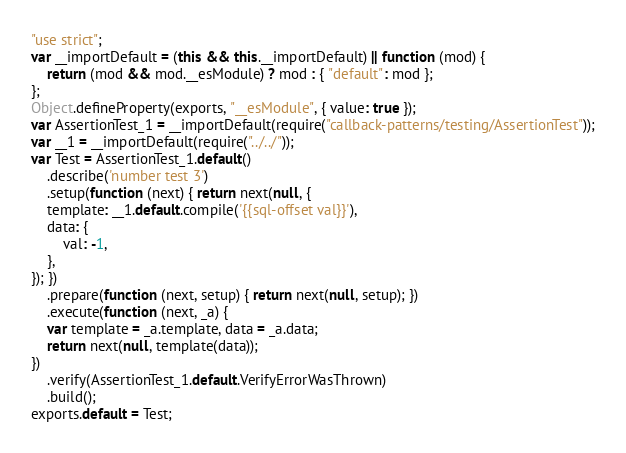<code> <loc_0><loc_0><loc_500><loc_500><_JavaScript_>"use strict";
var __importDefault = (this && this.__importDefault) || function (mod) {
    return (mod && mod.__esModule) ? mod : { "default": mod };
};
Object.defineProperty(exports, "__esModule", { value: true });
var AssertionTest_1 = __importDefault(require("callback-patterns/testing/AssertionTest"));
var __1 = __importDefault(require("../../"));
var Test = AssertionTest_1.default()
    .describe('number test 3')
    .setup(function (next) { return next(null, {
    template: __1.default.compile('{{sql-offset val}}'),
    data: {
        val: -1,
    },
}); })
    .prepare(function (next, setup) { return next(null, setup); })
    .execute(function (next, _a) {
    var template = _a.template, data = _a.data;
    return next(null, template(data));
})
    .verify(AssertionTest_1.default.VerifyErrorWasThrown)
    .build();
exports.default = Test;
</code> 